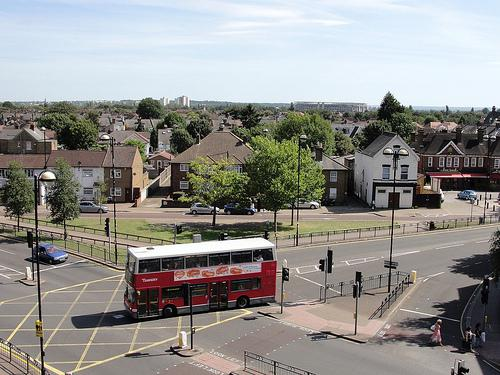Question: what kind of day it is?
Choices:
A. Sunny.
B. Dark.
C. Cloudy.
D. Windy.
Answer with the letter. Answer: A Question: where is the bus?
Choices:
A. In intersection.
B. Parked.
C. Highway.
D. Street corner.
Answer with the letter. Answer: A Question: who crossed the street?
Choices:
A. Kids.
B. People.
C. Police.
D. Fireman.
Answer with the letter. Answer: B Question: what is the color of the street?
Choices:
A. Black.
B. Tan.
C. Gray.
D. White.
Answer with the letter. Answer: C Question: what is the color of the bus?
Choices:
A. Blue.
B. White.
C. White and red.
D. Orange.
Answer with the letter. Answer: C 